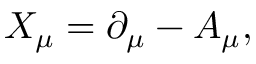Convert formula to latex. <formula><loc_0><loc_0><loc_500><loc_500>X _ { \mu } = \partial _ { \mu } - A _ { \mu } ,</formula> 